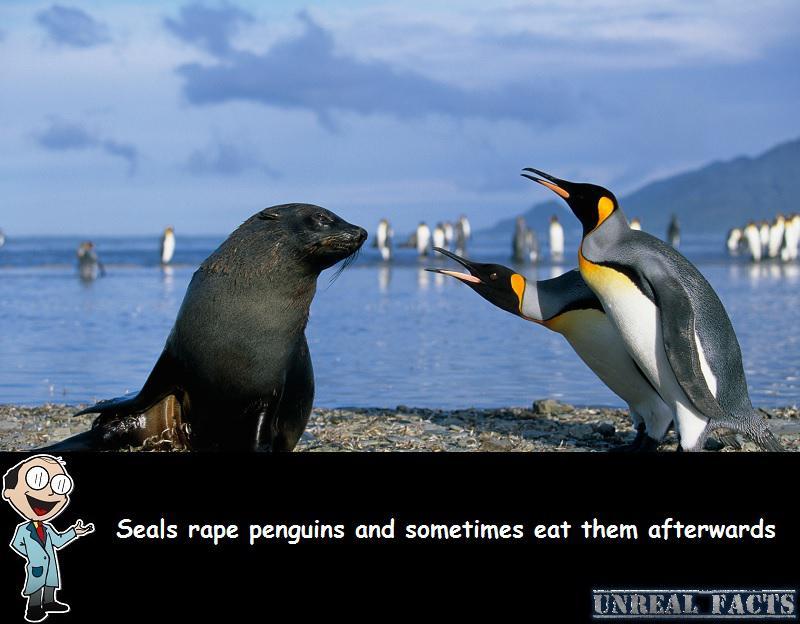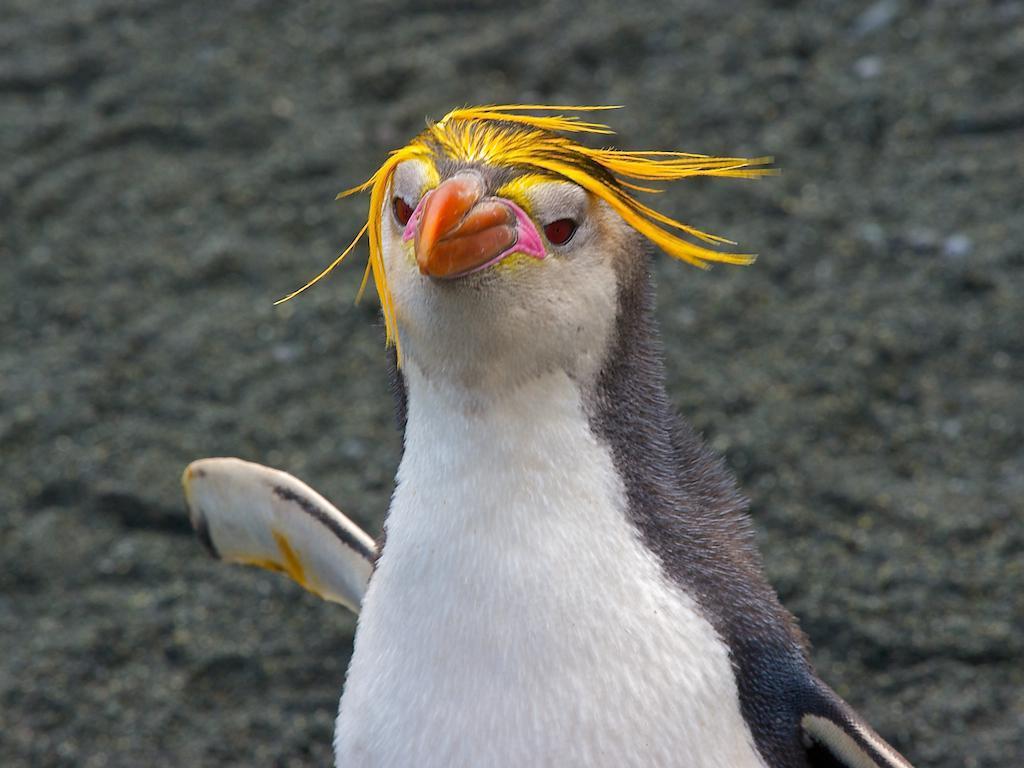The first image is the image on the left, the second image is the image on the right. For the images displayed, is the sentence "There is exactly one seal." factually correct? Answer yes or no. Yes. The first image is the image on the left, the second image is the image on the right. Assess this claim about the two images: "a penguin has molting feathers". Correct or not? Answer yes or no. No. 